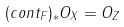Convert formula to latex. <formula><loc_0><loc_0><loc_500><loc_500>( c o n t _ { F } ) _ { * } O _ { X } = O _ { Z }</formula> 